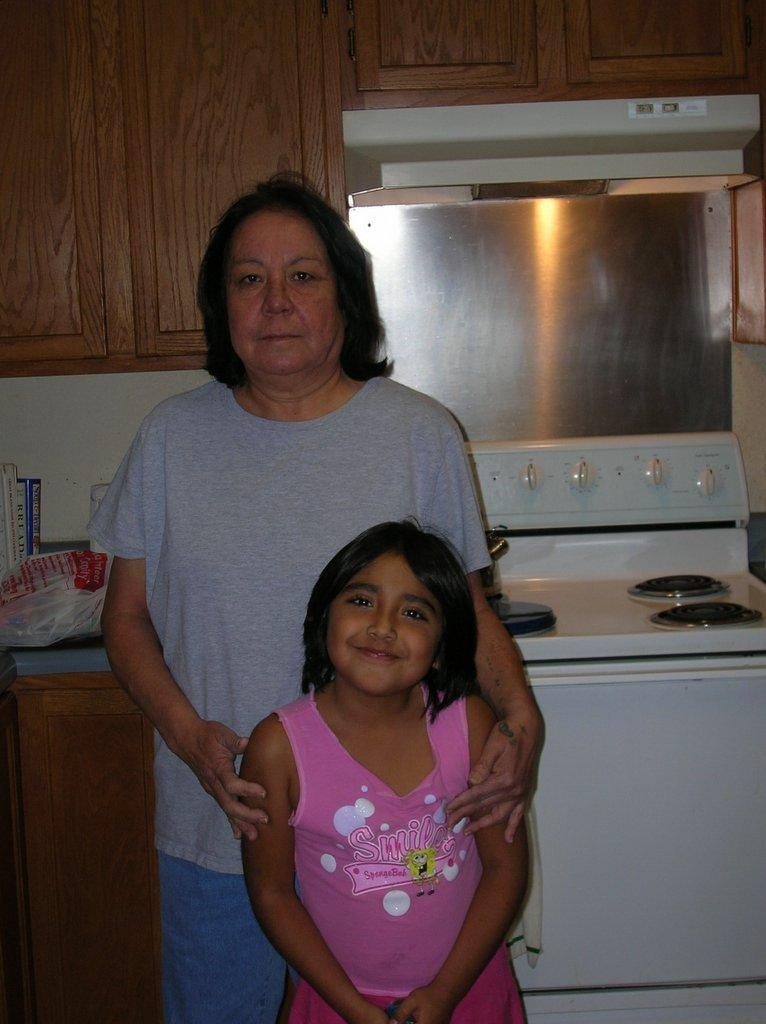<image>
Render a clear and concise summary of the photo. On the counter there is a Bread cookbook between two other books. 